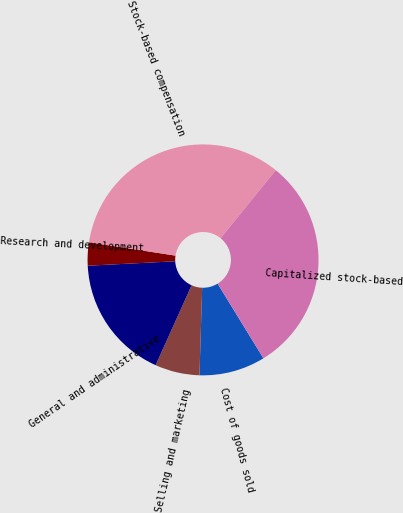Convert chart to OTSL. <chart><loc_0><loc_0><loc_500><loc_500><pie_chart><fcel>Cost of goods sold<fcel>Selling and marketing<fcel>General and administrative<fcel>Research and development<fcel>Stock-based compensation<fcel>Capitalized stock-based<nl><fcel>9.25%<fcel>6.24%<fcel>17.46%<fcel>3.24%<fcel>33.41%<fcel>30.4%<nl></chart> 